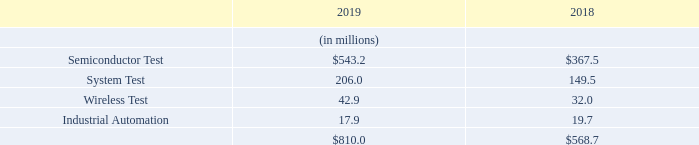Backlog
At December 31, 2019 and 2018, our backlog of unfilled orders in our four reportable segments was as follows:
Customers may delay delivery of products or cancel orders suddenly and without advanced notice, subject to possible cancellation penalties. Due to possible customer changes in delivery schedules and cancellation of orders, our backlog at any particular date is not necessarily indicative of the actual sales for any succeeding period. Delays in delivery schedules or cancellations of backlog during any particular period could have a material adverse effect on our business, financial condition or results of operations.
What can delays in delivery schedules or cancellations of backlog result in? Could have a material adverse effect on our business, financial condition or results of operations. What are the reportable segments in the table? Semiconductor test, system test, wireless test, industrial automation. In which years was the backlog of unfilled orders provided? 2019, 2018. In which year was Industrial Automation larger? 19.7>17.9
Answer: 2018. What was the change in Wireless Test in 2019 from 2018?
Answer scale should be: million. 42.9-32.0
Answer: 10.9. What was the percentage change in Wireless Test in 2019 from 2018?
Answer scale should be: percent. (42.9-32.0)/32.0
Answer: 34.06. 